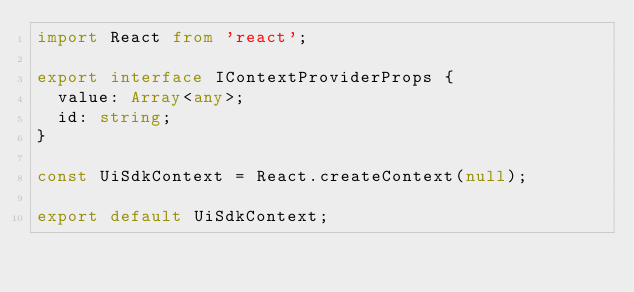Convert code to text. <code><loc_0><loc_0><loc_500><loc_500><_TypeScript_>import React from 'react';

export interface IContextProviderProps {
  value: Array<any>;
  id: string;
}

const UiSdkContext = React.createContext(null);

export default UiSdkContext;
</code> 